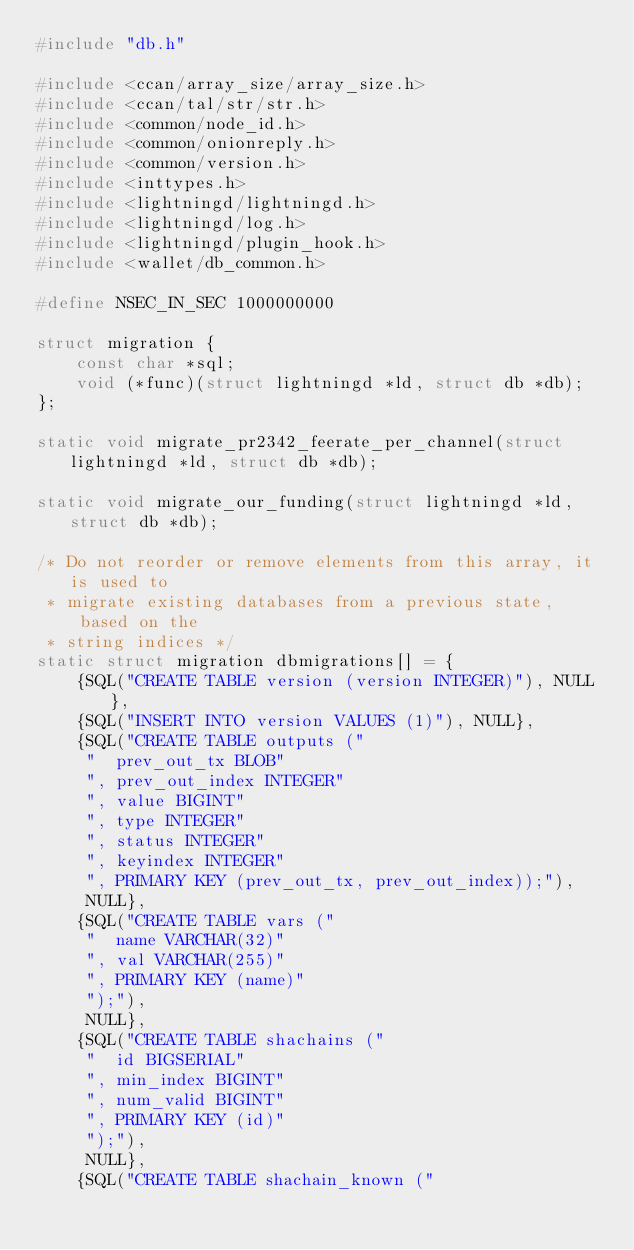Convert code to text. <code><loc_0><loc_0><loc_500><loc_500><_C_>#include "db.h"

#include <ccan/array_size/array_size.h>
#include <ccan/tal/str/str.h>
#include <common/node_id.h>
#include <common/onionreply.h>
#include <common/version.h>
#include <inttypes.h>
#include <lightningd/lightningd.h>
#include <lightningd/log.h>
#include <lightningd/plugin_hook.h>
#include <wallet/db_common.h>

#define NSEC_IN_SEC 1000000000

struct migration {
	const char *sql;
	void (*func)(struct lightningd *ld, struct db *db);
};

static void migrate_pr2342_feerate_per_channel(struct lightningd *ld, struct db *db);

static void migrate_our_funding(struct lightningd *ld, struct db *db);

/* Do not reorder or remove elements from this array, it is used to
 * migrate existing databases from a previous state, based on the
 * string indices */
static struct migration dbmigrations[] = {
    {SQL("CREATE TABLE version (version INTEGER)"), NULL},
    {SQL("INSERT INTO version VALUES (1)"), NULL},
    {SQL("CREATE TABLE outputs ("
	 "  prev_out_tx BLOB"
	 ", prev_out_index INTEGER"
	 ", value BIGINT"
	 ", type INTEGER"
	 ", status INTEGER"
	 ", keyindex INTEGER"
	 ", PRIMARY KEY (prev_out_tx, prev_out_index));"),
     NULL},
    {SQL("CREATE TABLE vars ("
	 "  name VARCHAR(32)"
	 ", val VARCHAR(255)"
	 ", PRIMARY KEY (name)"
	 ");"),
     NULL},
    {SQL("CREATE TABLE shachains ("
	 "  id BIGSERIAL"
	 ", min_index BIGINT"
	 ", num_valid BIGINT"
	 ", PRIMARY KEY (id)"
	 ");"),
     NULL},
    {SQL("CREATE TABLE shachain_known ("</code> 